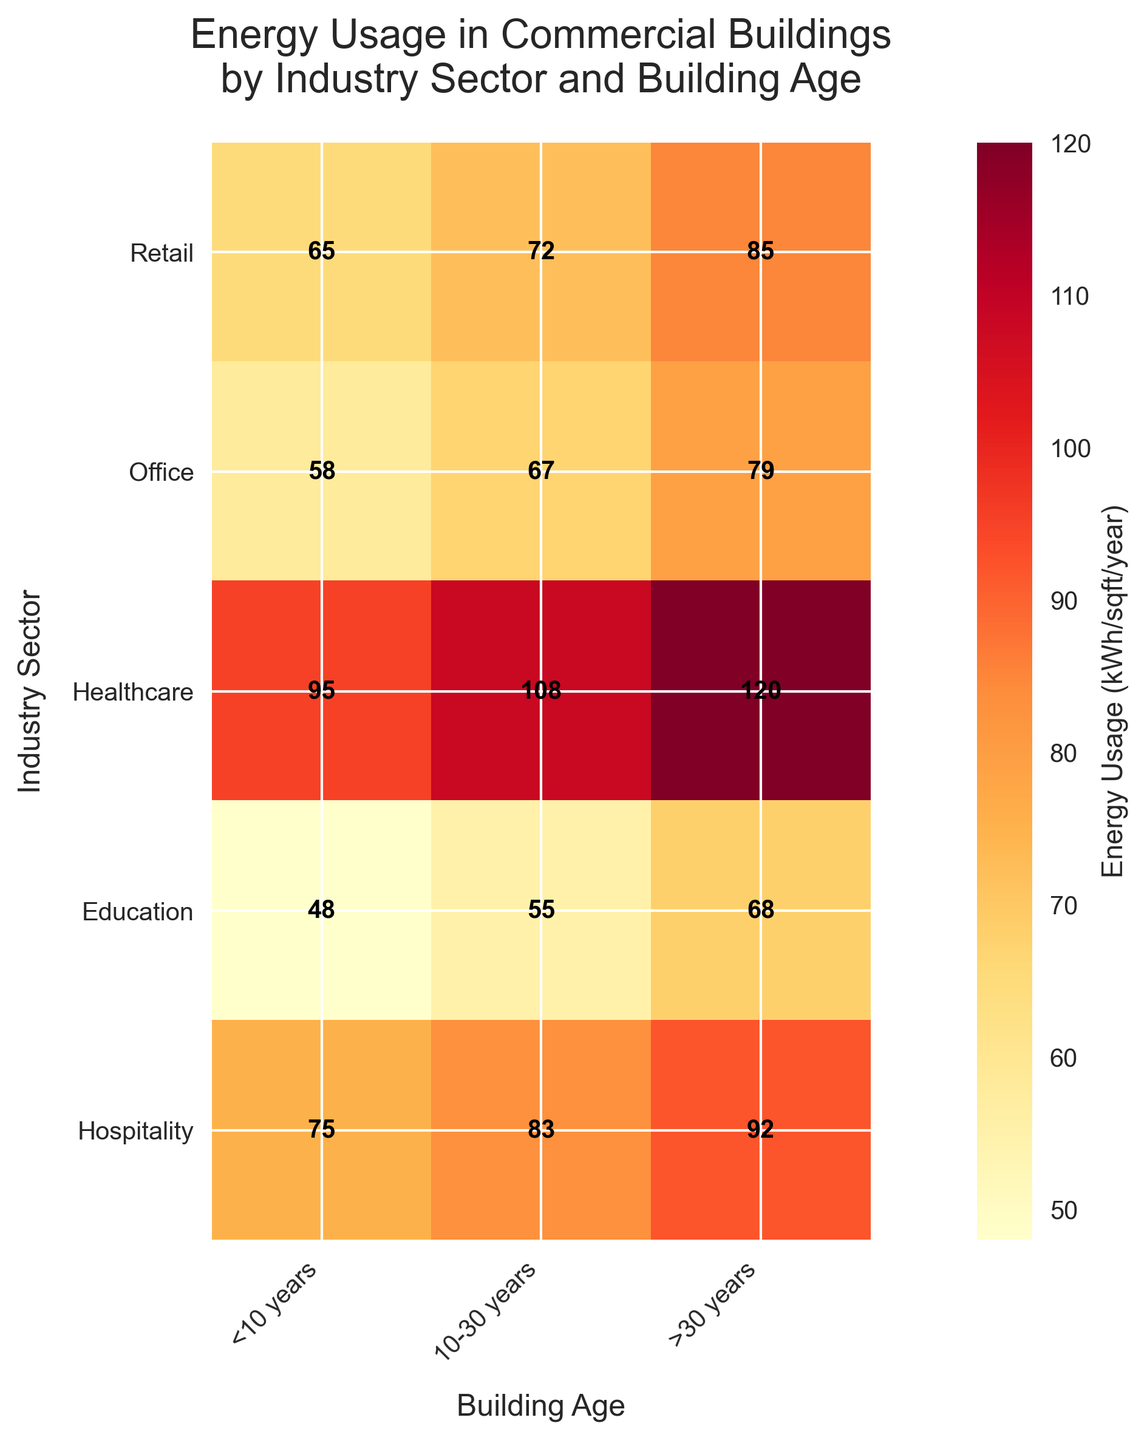What is the title of the figure? The title is typically found at the top of the figure. Here, it reads "Energy Usage in Commercial Buildings by Industry Sector and Building Age".
Answer: Energy Usage in Commercial Buildings by Industry Sector and Building Age Which industry sector has the highest energy usage in buildings older than 30 years? By looking at the rightmost column corresponding to '>30 years' and comparing all the rows, the highest value belongs to the 'Healthcare' sector.
Answer: Healthcare What is the energy usage for retail buildings that are 10-30 years old? Locate the 'Retail' row and find the cell corresponding to the '10-30 years' column. The value in that cell is 72 kWh/sqft/year.
Answer: 72 kWh/sqft/year How does the energy usage in <10-year-old buildings compare between the Healthcare and Retail sectors? Compare the values in the <10 years column for Healthcare and Retail sectors. Healthcare buildings use 95 kWh/sqft/year, while Retail buildings use 65 kWh/sqft/year.
Answer: Healthcare uses 30 kWh/sqft/year more By how much does energy usage increase in office buildings going from <10 years to >30 years? Subtract the energy usage for office buildings <10 years (58) from the energy usage for office buildings >30 years (79). So, 79 - 58 = 21 kWh/sqft/year.
Answer: 21 kWh/sqft/year Which building age group has the lowest energy usage for education buildings? Compare the three values for Education buildings across all age groups: <10 years (48), 10-30 years (55), and >30 years (68). The lowest value is 48 kWh/sqft/year, which corresponds to <10 years.
Answer: <10 years What is the average energy usage for Hospitality buildings across all age groups? Find the values for Hospitality buildings across all age groups: 75, 83, and 92. Then calculate the average: (75 + 83 + 92) / 3 = 83.33 (rounded to two decimal places).
Answer: 83.33 kWh/sqft/year Is there any industry sector where the energy usage does not exceed 100 kWh/sqft/year for any building age group? Review all values for each sector. The sectors where none of the values exceed 100 are Retail, Office, Education, and Hospitality.
Answer: Retail, Office, Education, Hospitality 